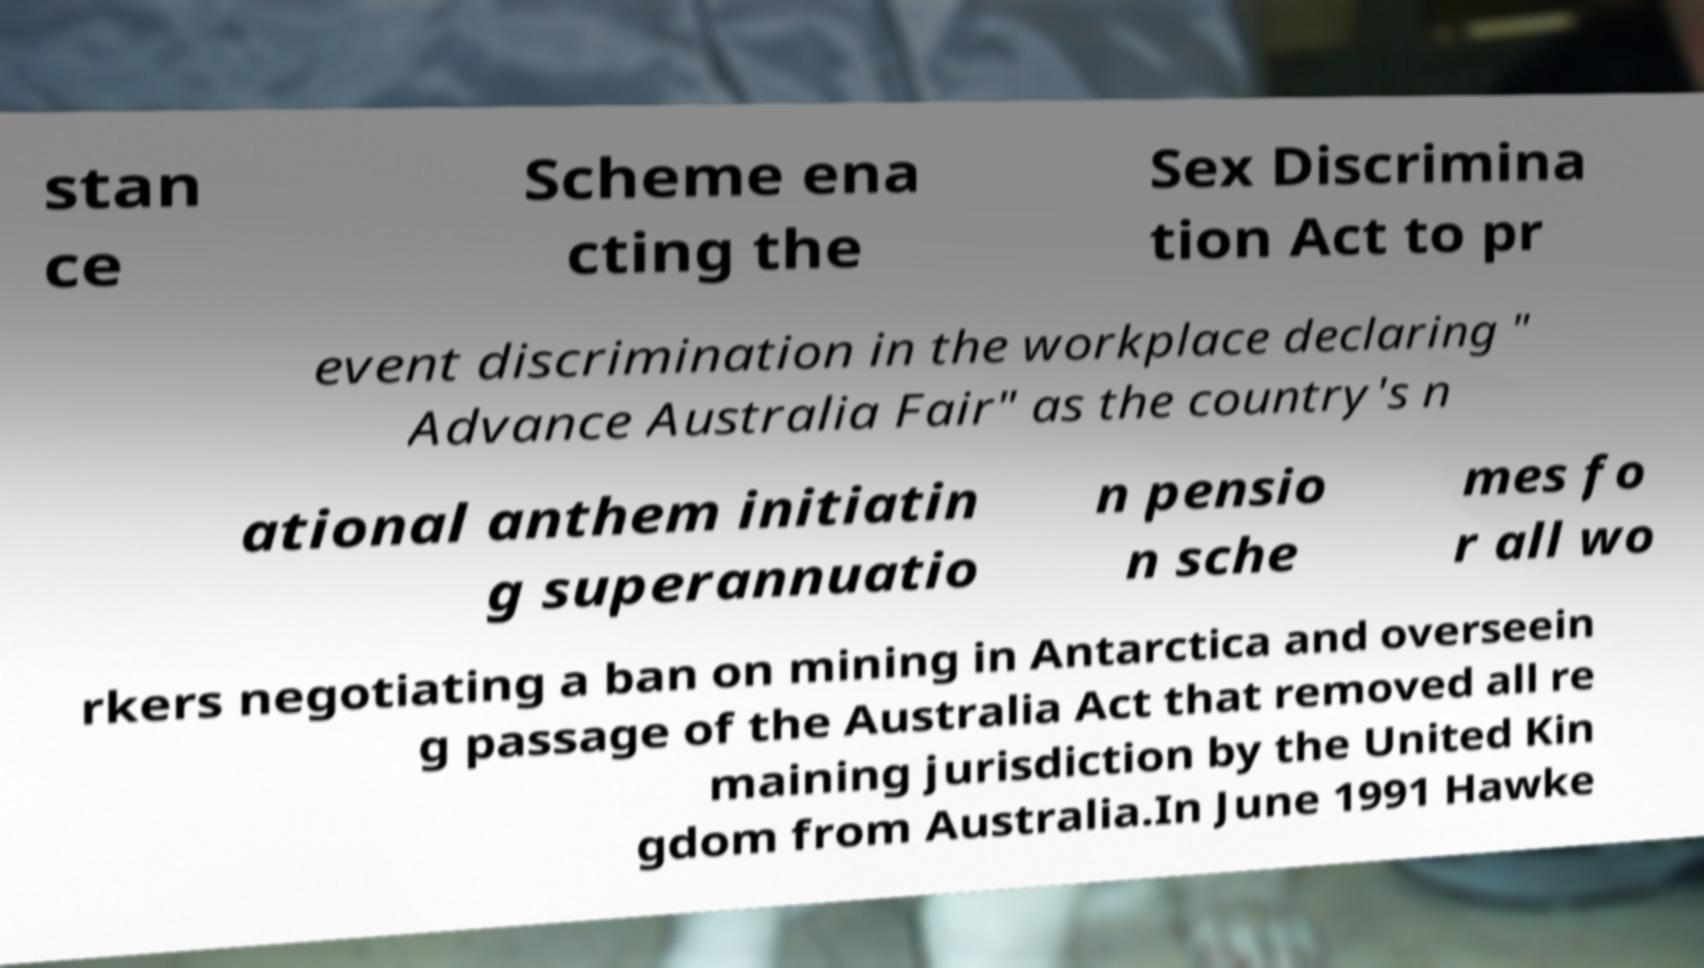I need the written content from this picture converted into text. Can you do that? stan ce Scheme ena cting the Sex Discrimina tion Act to pr event discrimination in the workplace declaring " Advance Australia Fair" as the country's n ational anthem initiatin g superannuatio n pensio n sche mes fo r all wo rkers negotiating a ban on mining in Antarctica and overseein g passage of the Australia Act that removed all re maining jurisdiction by the United Kin gdom from Australia.In June 1991 Hawke 